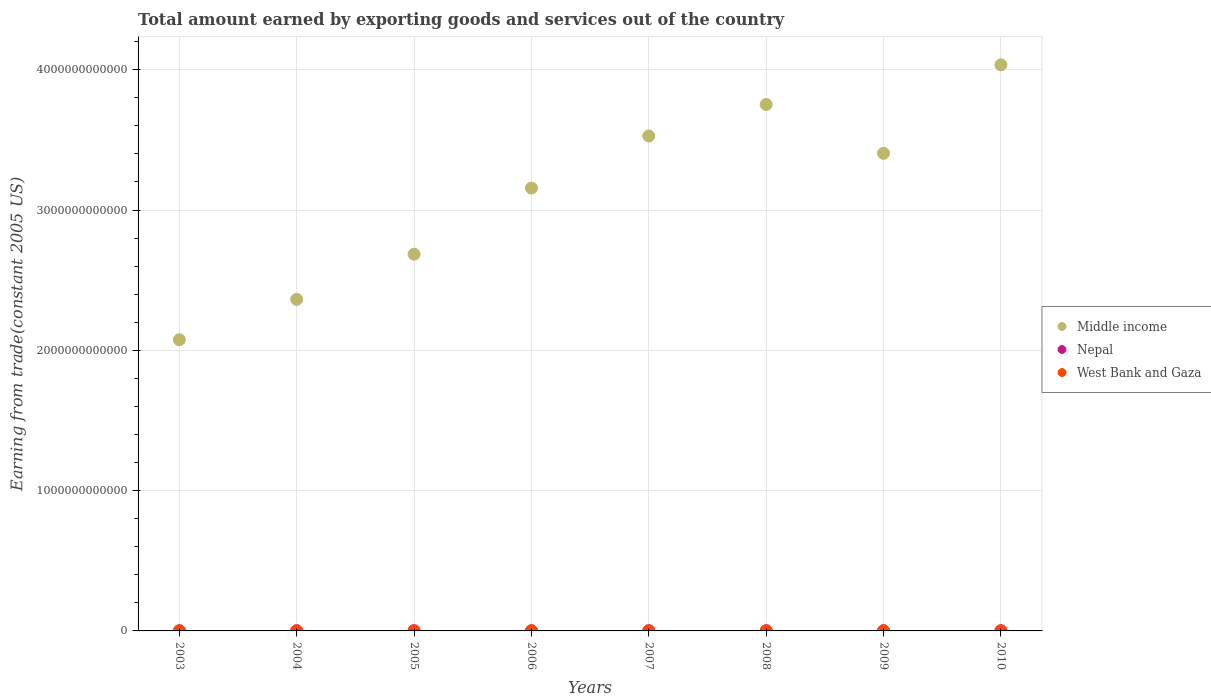What is the total amount earned by exporting goods and services in West Bank and Gaza in 2008?
Ensure brevity in your answer.  7.71e+08. Across all years, what is the maximum total amount earned by exporting goods and services in Middle income?
Offer a terse response. 4.03e+12. Across all years, what is the minimum total amount earned by exporting goods and services in West Bank and Gaza?
Your response must be concise. 5.62e+08. In which year was the total amount earned by exporting goods and services in Nepal maximum?
Provide a short and direct response. 2004. In which year was the total amount earned by exporting goods and services in West Bank and Gaza minimum?
Offer a terse response. 2003. What is the total total amount earned by exporting goods and services in Nepal in the graph?
Your answer should be very brief. 9.29e+09. What is the difference between the total amount earned by exporting goods and services in Nepal in 2007 and that in 2009?
Your answer should be compact. -5.36e+07. What is the difference between the total amount earned by exporting goods and services in Middle income in 2005 and the total amount earned by exporting goods and services in West Bank and Gaza in 2010?
Provide a succinct answer. 2.68e+12. What is the average total amount earned by exporting goods and services in Nepal per year?
Your answer should be compact. 1.16e+09. In the year 2009, what is the difference between the total amount earned by exporting goods and services in Middle income and total amount earned by exporting goods and services in Nepal?
Your answer should be very brief. 3.40e+12. In how many years, is the total amount earned by exporting goods and services in West Bank and Gaza greater than 2200000000000 US$?
Your answer should be very brief. 0. What is the ratio of the total amount earned by exporting goods and services in Middle income in 2005 to that in 2010?
Your answer should be very brief. 0.67. Is the difference between the total amount earned by exporting goods and services in Middle income in 2006 and 2009 greater than the difference between the total amount earned by exporting goods and services in Nepal in 2006 and 2009?
Ensure brevity in your answer.  No. What is the difference between the highest and the second highest total amount earned by exporting goods and services in Nepal?
Ensure brevity in your answer.  9.86e+06. What is the difference between the highest and the lowest total amount earned by exporting goods and services in West Bank and Gaza?
Offer a terse response. 3.54e+08. In how many years, is the total amount earned by exporting goods and services in Middle income greater than the average total amount earned by exporting goods and services in Middle income taken over all years?
Provide a succinct answer. 5. Is it the case that in every year, the sum of the total amount earned by exporting goods and services in Nepal and total amount earned by exporting goods and services in West Bank and Gaza  is greater than the total amount earned by exporting goods and services in Middle income?
Ensure brevity in your answer.  No. Does the total amount earned by exporting goods and services in West Bank and Gaza monotonically increase over the years?
Keep it short and to the point. No. Is the total amount earned by exporting goods and services in West Bank and Gaza strictly greater than the total amount earned by exporting goods and services in Middle income over the years?
Provide a succinct answer. No. Is the total amount earned by exporting goods and services in Nepal strictly less than the total amount earned by exporting goods and services in West Bank and Gaza over the years?
Your answer should be compact. No. How many dotlines are there?
Keep it short and to the point. 3. How many years are there in the graph?
Give a very brief answer. 8. What is the difference between two consecutive major ticks on the Y-axis?
Offer a terse response. 1.00e+12. Does the graph contain any zero values?
Offer a very short reply. No. How many legend labels are there?
Your answer should be compact. 3. How are the legend labels stacked?
Offer a very short reply. Vertical. What is the title of the graph?
Your answer should be compact. Total amount earned by exporting goods and services out of the country. What is the label or title of the Y-axis?
Your response must be concise. Earning from trade(constant 2005 US). What is the Earning from trade(constant 2005 US) in Middle income in 2003?
Offer a very short reply. 2.08e+12. What is the Earning from trade(constant 2005 US) of Nepal in 2003?
Keep it short and to the point. 1.09e+09. What is the Earning from trade(constant 2005 US) of West Bank and Gaza in 2003?
Ensure brevity in your answer.  5.62e+08. What is the Earning from trade(constant 2005 US) in Middle income in 2004?
Your answer should be compact. 2.36e+12. What is the Earning from trade(constant 2005 US) in Nepal in 2004?
Your response must be concise. 1.22e+09. What is the Earning from trade(constant 2005 US) of West Bank and Gaza in 2004?
Your answer should be compact. 6.12e+08. What is the Earning from trade(constant 2005 US) of Middle income in 2005?
Make the answer very short. 2.69e+12. What is the Earning from trade(constant 2005 US) of Nepal in 2005?
Give a very brief answer. 1.19e+09. What is the Earning from trade(constant 2005 US) in West Bank and Gaza in 2005?
Your response must be concise. 7.24e+08. What is the Earning from trade(constant 2005 US) of Middle income in 2006?
Make the answer very short. 3.16e+12. What is the Earning from trade(constant 2005 US) of Nepal in 2006?
Your answer should be very brief. 1.17e+09. What is the Earning from trade(constant 2005 US) of West Bank and Gaza in 2006?
Provide a succinct answer. 6.97e+08. What is the Earning from trade(constant 2005 US) in Middle income in 2007?
Offer a very short reply. 3.53e+12. What is the Earning from trade(constant 2005 US) in Nepal in 2007?
Make the answer very short. 1.16e+09. What is the Earning from trade(constant 2005 US) of West Bank and Gaza in 2007?
Your answer should be compact. 7.63e+08. What is the Earning from trade(constant 2005 US) of Middle income in 2008?
Your response must be concise. 3.75e+12. What is the Earning from trade(constant 2005 US) of Nepal in 2008?
Your answer should be very brief. 1.17e+09. What is the Earning from trade(constant 2005 US) in West Bank and Gaza in 2008?
Provide a succinct answer. 7.71e+08. What is the Earning from trade(constant 2005 US) of Middle income in 2009?
Offer a terse response. 3.40e+12. What is the Earning from trade(constant 2005 US) of Nepal in 2009?
Provide a succinct answer. 1.21e+09. What is the Earning from trade(constant 2005 US) of West Bank and Gaza in 2009?
Give a very brief answer. 9.15e+08. What is the Earning from trade(constant 2005 US) in Middle income in 2010?
Keep it short and to the point. 4.03e+12. What is the Earning from trade(constant 2005 US) in Nepal in 2010?
Keep it short and to the point. 1.09e+09. What is the Earning from trade(constant 2005 US) in West Bank and Gaza in 2010?
Give a very brief answer. 8.80e+08. Across all years, what is the maximum Earning from trade(constant 2005 US) in Middle income?
Give a very brief answer. 4.03e+12. Across all years, what is the maximum Earning from trade(constant 2005 US) of Nepal?
Offer a terse response. 1.22e+09. Across all years, what is the maximum Earning from trade(constant 2005 US) of West Bank and Gaza?
Your response must be concise. 9.15e+08. Across all years, what is the minimum Earning from trade(constant 2005 US) of Middle income?
Provide a short and direct response. 2.08e+12. Across all years, what is the minimum Earning from trade(constant 2005 US) in Nepal?
Ensure brevity in your answer.  1.09e+09. Across all years, what is the minimum Earning from trade(constant 2005 US) of West Bank and Gaza?
Offer a very short reply. 5.62e+08. What is the total Earning from trade(constant 2005 US) of Middle income in the graph?
Provide a short and direct response. 2.50e+13. What is the total Earning from trade(constant 2005 US) in Nepal in the graph?
Provide a succinct answer. 9.29e+09. What is the total Earning from trade(constant 2005 US) of West Bank and Gaza in the graph?
Ensure brevity in your answer.  5.92e+09. What is the difference between the Earning from trade(constant 2005 US) of Middle income in 2003 and that in 2004?
Your response must be concise. -2.88e+11. What is the difference between the Earning from trade(constant 2005 US) of Nepal in 2003 and that in 2004?
Provide a succinct answer. -1.34e+08. What is the difference between the Earning from trade(constant 2005 US) in West Bank and Gaza in 2003 and that in 2004?
Your answer should be compact. -5.02e+07. What is the difference between the Earning from trade(constant 2005 US) in Middle income in 2003 and that in 2005?
Provide a short and direct response. -6.10e+11. What is the difference between the Earning from trade(constant 2005 US) in Nepal in 2003 and that in 2005?
Keep it short and to the point. -9.66e+07. What is the difference between the Earning from trade(constant 2005 US) of West Bank and Gaza in 2003 and that in 2005?
Offer a very short reply. -1.62e+08. What is the difference between the Earning from trade(constant 2005 US) in Middle income in 2003 and that in 2006?
Make the answer very short. -1.08e+12. What is the difference between the Earning from trade(constant 2005 US) of Nepal in 2003 and that in 2006?
Offer a very short reply. -8.13e+07. What is the difference between the Earning from trade(constant 2005 US) of West Bank and Gaza in 2003 and that in 2006?
Provide a succinct answer. -1.36e+08. What is the difference between the Earning from trade(constant 2005 US) in Middle income in 2003 and that in 2007?
Provide a succinct answer. -1.45e+12. What is the difference between the Earning from trade(constant 2005 US) in Nepal in 2003 and that in 2007?
Make the answer very short. -7.02e+07. What is the difference between the Earning from trade(constant 2005 US) in West Bank and Gaza in 2003 and that in 2007?
Provide a short and direct response. -2.02e+08. What is the difference between the Earning from trade(constant 2005 US) in Middle income in 2003 and that in 2008?
Provide a succinct answer. -1.68e+12. What is the difference between the Earning from trade(constant 2005 US) in Nepal in 2003 and that in 2008?
Provide a short and direct response. -7.86e+07. What is the difference between the Earning from trade(constant 2005 US) in West Bank and Gaza in 2003 and that in 2008?
Provide a succinct answer. -2.09e+08. What is the difference between the Earning from trade(constant 2005 US) in Middle income in 2003 and that in 2009?
Your response must be concise. -1.33e+12. What is the difference between the Earning from trade(constant 2005 US) of Nepal in 2003 and that in 2009?
Give a very brief answer. -1.24e+08. What is the difference between the Earning from trade(constant 2005 US) in West Bank and Gaza in 2003 and that in 2009?
Offer a terse response. -3.54e+08. What is the difference between the Earning from trade(constant 2005 US) of Middle income in 2003 and that in 2010?
Give a very brief answer. -1.96e+12. What is the difference between the Earning from trade(constant 2005 US) of Nepal in 2003 and that in 2010?
Keep it short and to the point. 2.77e+06. What is the difference between the Earning from trade(constant 2005 US) of West Bank and Gaza in 2003 and that in 2010?
Provide a short and direct response. -3.19e+08. What is the difference between the Earning from trade(constant 2005 US) in Middle income in 2004 and that in 2005?
Ensure brevity in your answer.  -3.22e+11. What is the difference between the Earning from trade(constant 2005 US) of Nepal in 2004 and that in 2005?
Offer a terse response. 3.71e+07. What is the difference between the Earning from trade(constant 2005 US) of West Bank and Gaza in 2004 and that in 2005?
Your answer should be very brief. -1.12e+08. What is the difference between the Earning from trade(constant 2005 US) in Middle income in 2004 and that in 2006?
Provide a short and direct response. -7.93e+11. What is the difference between the Earning from trade(constant 2005 US) in Nepal in 2004 and that in 2006?
Ensure brevity in your answer.  5.24e+07. What is the difference between the Earning from trade(constant 2005 US) of West Bank and Gaza in 2004 and that in 2006?
Give a very brief answer. -8.56e+07. What is the difference between the Earning from trade(constant 2005 US) of Middle income in 2004 and that in 2007?
Offer a terse response. -1.16e+12. What is the difference between the Earning from trade(constant 2005 US) in Nepal in 2004 and that in 2007?
Offer a very short reply. 6.35e+07. What is the difference between the Earning from trade(constant 2005 US) in West Bank and Gaza in 2004 and that in 2007?
Give a very brief answer. -1.51e+08. What is the difference between the Earning from trade(constant 2005 US) in Middle income in 2004 and that in 2008?
Give a very brief answer. -1.39e+12. What is the difference between the Earning from trade(constant 2005 US) in Nepal in 2004 and that in 2008?
Provide a succinct answer. 5.51e+07. What is the difference between the Earning from trade(constant 2005 US) in West Bank and Gaza in 2004 and that in 2008?
Ensure brevity in your answer.  -1.59e+08. What is the difference between the Earning from trade(constant 2005 US) of Middle income in 2004 and that in 2009?
Your answer should be very brief. -1.04e+12. What is the difference between the Earning from trade(constant 2005 US) of Nepal in 2004 and that in 2009?
Provide a short and direct response. 9.86e+06. What is the difference between the Earning from trade(constant 2005 US) in West Bank and Gaza in 2004 and that in 2009?
Your answer should be compact. -3.03e+08. What is the difference between the Earning from trade(constant 2005 US) of Middle income in 2004 and that in 2010?
Your answer should be compact. -1.67e+12. What is the difference between the Earning from trade(constant 2005 US) of Nepal in 2004 and that in 2010?
Offer a terse response. 1.36e+08. What is the difference between the Earning from trade(constant 2005 US) in West Bank and Gaza in 2004 and that in 2010?
Your answer should be very brief. -2.69e+08. What is the difference between the Earning from trade(constant 2005 US) of Middle income in 2005 and that in 2006?
Your response must be concise. -4.71e+11. What is the difference between the Earning from trade(constant 2005 US) of Nepal in 2005 and that in 2006?
Offer a very short reply. 1.53e+07. What is the difference between the Earning from trade(constant 2005 US) of West Bank and Gaza in 2005 and that in 2006?
Offer a very short reply. 2.63e+07. What is the difference between the Earning from trade(constant 2005 US) in Middle income in 2005 and that in 2007?
Your response must be concise. -8.43e+11. What is the difference between the Earning from trade(constant 2005 US) of Nepal in 2005 and that in 2007?
Keep it short and to the point. 2.64e+07. What is the difference between the Earning from trade(constant 2005 US) of West Bank and Gaza in 2005 and that in 2007?
Ensure brevity in your answer.  -3.95e+07. What is the difference between the Earning from trade(constant 2005 US) of Middle income in 2005 and that in 2008?
Keep it short and to the point. -1.07e+12. What is the difference between the Earning from trade(constant 2005 US) in Nepal in 2005 and that in 2008?
Provide a short and direct response. 1.80e+07. What is the difference between the Earning from trade(constant 2005 US) of West Bank and Gaza in 2005 and that in 2008?
Keep it short and to the point. -4.70e+07. What is the difference between the Earning from trade(constant 2005 US) of Middle income in 2005 and that in 2009?
Provide a short and direct response. -7.19e+11. What is the difference between the Earning from trade(constant 2005 US) of Nepal in 2005 and that in 2009?
Provide a succinct answer. -2.72e+07. What is the difference between the Earning from trade(constant 2005 US) of West Bank and Gaza in 2005 and that in 2009?
Keep it short and to the point. -1.91e+08. What is the difference between the Earning from trade(constant 2005 US) of Middle income in 2005 and that in 2010?
Keep it short and to the point. -1.35e+12. What is the difference between the Earning from trade(constant 2005 US) in Nepal in 2005 and that in 2010?
Provide a short and direct response. 9.94e+07. What is the difference between the Earning from trade(constant 2005 US) in West Bank and Gaza in 2005 and that in 2010?
Provide a succinct answer. -1.57e+08. What is the difference between the Earning from trade(constant 2005 US) of Middle income in 2006 and that in 2007?
Offer a terse response. -3.71e+11. What is the difference between the Earning from trade(constant 2005 US) in Nepal in 2006 and that in 2007?
Make the answer very short. 1.11e+07. What is the difference between the Earning from trade(constant 2005 US) in West Bank and Gaza in 2006 and that in 2007?
Offer a very short reply. -6.57e+07. What is the difference between the Earning from trade(constant 2005 US) of Middle income in 2006 and that in 2008?
Give a very brief answer. -5.96e+11. What is the difference between the Earning from trade(constant 2005 US) of Nepal in 2006 and that in 2008?
Your response must be concise. 2.63e+06. What is the difference between the Earning from trade(constant 2005 US) of West Bank and Gaza in 2006 and that in 2008?
Give a very brief answer. -7.32e+07. What is the difference between the Earning from trade(constant 2005 US) of Middle income in 2006 and that in 2009?
Keep it short and to the point. -2.48e+11. What is the difference between the Earning from trade(constant 2005 US) in Nepal in 2006 and that in 2009?
Make the answer very short. -4.26e+07. What is the difference between the Earning from trade(constant 2005 US) in West Bank and Gaza in 2006 and that in 2009?
Give a very brief answer. -2.18e+08. What is the difference between the Earning from trade(constant 2005 US) of Middle income in 2006 and that in 2010?
Your response must be concise. -8.78e+11. What is the difference between the Earning from trade(constant 2005 US) of Nepal in 2006 and that in 2010?
Your response must be concise. 8.40e+07. What is the difference between the Earning from trade(constant 2005 US) of West Bank and Gaza in 2006 and that in 2010?
Offer a terse response. -1.83e+08. What is the difference between the Earning from trade(constant 2005 US) in Middle income in 2007 and that in 2008?
Keep it short and to the point. -2.24e+11. What is the difference between the Earning from trade(constant 2005 US) in Nepal in 2007 and that in 2008?
Offer a very short reply. -8.43e+06. What is the difference between the Earning from trade(constant 2005 US) in West Bank and Gaza in 2007 and that in 2008?
Keep it short and to the point. -7.48e+06. What is the difference between the Earning from trade(constant 2005 US) of Middle income in 2007 and that in 2009?
Ensure brevity in your answer.  1.23e+11. What is the difference between the Earning from trade(constant 2005 US) in Nepal in 2007 and that in 2009?
Your answer should be very brief. -5.36e+07. What is the difference between the Earning from trade(constant 2005 US) in West Bank and Gaza in 2007 and that in 2009?
Give a very brief answer. -1.52e+08. What is the difference between the Earning from trade(constant 2005 US) of Middle income in 2007 and that in 2010?
Your response must be concise. -5.07e+11. What is the difference between the Earning from trade(constant 2005 US) of Nepal in 2007 and that in 2010?
Your response must be concise. 7.30e+07. What is the difference between the Earning from trade(constant 2005 US) of West Bank and Gaza in 2007 and that in 2010?
Your response must be concise. -1.17e+08. What is the difference between the Earning from trade(constant 2005 US) of Middle income in 2008 and that in 2009?
Ensure brevity in your answer.  3.48e+11. What is the difference between the Earning from trade(constant 2005 US) in Nepal in 2008 and that in 2009?
Your response must be concise. -4.52e+07. What is the difference between the Earning from trade(constant 2005 US) of West Bank and Gaza in 2008 and that in 2009?
Keep it short and to the point. -1.45e+08. What is the difference between the Earning from trade(constant 2005 US) of Middle income in 2008 and that in 2010?
Offer a terse response. -2.83e+11. What is the difference between the Earning from trade(constant 2005 US) in Nepal in 2008 and that in 2010?
Provide a succinct answer. 8.14e+07. What is the difference between the Earning from trade(constant 2005 US) of West Bank and Gaza in 2008 and that in 2010?
Give a very brief answer. -1.10e+08. What is the difference between the Earning from trade(constant 2005 US) in Middle income in 2009 and that in 2010?
Your response must be concise. -6.30e+11. What is the difference between the Earning from trade(constant 2005 US) of Nepal in 2009 and that in 2010?
Keep it short and to the point. 1.27e+08. What is the difference between the Earning from trade(constant 2005 US) in West Bank and Gaza in 2009 and that in 2010?
Keep it short and to the point. 3.47e+07. What is the difference between the Earning from trade(constant 2005 US) of Middle income in 2003 and the Earning from trade(constant 2005 US) of Nepal in 2004?
Provide a short and direct response. 2.07e+12. What is the difference between the Earning from trade(constant 2005 US) in Middle income in 2003 and the Earning from trade(constant 2005 US) in West Bank and Gaza in 2004?
Give a very brief answer. 2.07e+12. What is the difference between the Earning from trade(constant 2005 US) in Nepal in 2003 and the Earning from trade(constant 2005 US) in West Bank and Gaza in 2004?
Your answer should be very brief. 4.77e+08. What is the difference between the Earning from trade(constant 2005 US) of Middle income in 2003 and the Earning from trade(constant 2005 US) of Nepal in 2005?
Provide a short and direct response. 2.07e+12. What is the difference between the Earning from trade(constant 2005 US) in Middle income in 2003 and the Earning from trade(constant 2005 US) in West Bank and Gaza in 2005?
Your answer should be compact. 2.07e+12. What is the difference between the Earning from trade(constant 2005 US) in Nepal in 2003 and the Earning from trade(constant 2005 US) in West Bank and Gaza in 2005?
Offer a terse response. 3.65e+08. What is the difference between the Earning from trade(constant 2005 US) of Middle income in 2003 and the Earning from trade(constant 2005 US) of Nepal in 2006?
Your answer should be compact. 2.07e+12. What is the difference between the Earning from trade(constant 2005 US) in Middle income in 2003 and the Earning from trade(constant 2005 US) in West Bank and Gaza in 2006?
Give a very brief answer. 2.07e+12. What is the difference between the Earning from trade(constant 2005 US) of Nepal in 2003 and the Earning from trade(constant 2005 US) of West Bank and Gaza in 2006?
Offer a very short reply. 3.92e+08. What is the difference between the Earning from trade(constant 2005 US) of Middle income in 2003 and the Earning from trade(constant 2005 US) of Nepal in 2007?
Offer a very short reply. 2.07e+12. What is the difference between the Earning from trade(constant 2005 US) in Middle income in 2003 and the Earning from trade(constant 2005 US) in West Bank and Gaza in 2007?
Provide a succinct answer. 2.07e+12. What is the difference between the Earning from trade(constant 2005 US) in Nepal in 2003 and the Earning from trade(constant 2005 US) in West Bank and Gaza in 2007?
Your response must be concise. 3.26e+08. What is the difference between the Earning from trade(constant 2005 US) of Middle income in 2003 and the Earning from trade(constant 2005 US) of Nepal in 2008?
Provide a succinct answer. 2.07e+12. What is the difference between the Earning from trade(constant 2005 US) of Middle income in 2003 and the Earning from trade(constant 2005 US) of West Bank and Gaza in 2008?
Your response must be concise. 2.07e+12. What is the difference between the Earning from trade(constant 2005 US) of Nepal in 2003 and the Earning from trade(constant 2005 US) of West Bank and Gaza in 2008?
Your answer should be compact. 3.18e+08. What is the difference between the Earning from trade(constant 2005 US) in Middle income in 2003 and the Earning from trade(constant 2005 US) in Nepal in 2009?
Provide a short and direct response. 2.07e+12. What is the difference between the Earning from trade(constant 2005 US) in Middle income in 2003 and the Earning from trade(constant 2005 US) in West Bank and Gaza in 2009?
Provide a succinct answer. 2.07e+12. What is the difference between the Earning from trade(constant 2005 US) in Nepal in 2003 and the Earning from trade(constant 2005 US) in West Bank and Gaza in 2009?
Your answer should be compact. 1.74e+08. What is the difference between the Earning from trade(constant 2005 US) in Middle income in 2003 and the Earning from trade(constant 2005 US) in Nepal in 2010?
Ensure brevity in your answer.  2.07e+12. What is the difference between the Earning from trade(constant 2005 US) in Middle income in 2003 and the Earning from trade(constant 2005 US) in West Bank and Gaza in 2010?
Provide a short and direct response. 2.07e+12. What is the difference between the Earning from trade(constant 2005 US) in Nepal in 2003 and the Earning from trade(constant 2005 US) in West Bank and Gaza in 2010?
Your answer should be very brief. 2.09e+08. What is the difference between the Earning from trade(constant 2005 US) of Middle income in 2004 and the Earning from trade(constant 2005 US) of Nepal in 2005?
Provide a succinct answer. 2.36e+12. What is the difference between the Earning from trade(constant 2005 US) in Middle income in 2004 and the Earning from trade(constant 2005 US) in West Bank and Gaza in 2005?
Offer a very short reply. 2.36e+12. What is the difference between the Earning from trade(constant 2005 US) of Nepal in 2004 and the Earning from trade(constant 2005 US) of West Bank and Gaza in 2005?
Make the answer very short. 4.99e+08. What is the difference between the Earning from trade(constant 2005 US) in Middle income in 2004 and the Earning from trade(constant 2005 US) in Nepal in 2006?
Your answer should be very brief. 2.36e+12. What is the difference between the Earning from trade(constant 2005 US) in Middle income in 2004 and the Earning from trade(constant 2005 US) in West Bank and Gaza in 2006?
Keep it short and to the point. 2.36e+12. What is the difference between the Earning from trade(constant 2005 US) in Nepal in 2004 and the Earning from trade(constant 2005 US) in West Bank and Gaza in 2006?
Offer a terse response. 5.25e+08. What is the difference between the Earning from trade(constant 2005 US) in Middle income in 2004 and the Earning from trade(constant 2005 US) in Nepal in 2007?
Offer a very short reply. 2.36e+12. What is the difference between the Earning from trade(constant 2005 US) of Middle income in 2004 and the Earning from trade(constant 2005 US) of West Bank and Gaza in 2007?
Keep it short and to the point. 2.36e+12. What is the difference between the Earning from trade(constant 2005 US) of Nepal in 2004 and the Earning from trade(constant 2005 US) of West Bank and Gaza in 2007?
Provide a succinct answer. 4.60e+08. What is the difference between the Earning from trade(constant 2005 US) of Middle income in 2004 and the Earning from trade(constant 2005 US) of Nepal in 2008?
Offer a very short reply. 2.36e+12. What is the difference between the Earning from trade(constant 2005 US) in Middle income in 2004 and the Earning from trade(constant 2005 US) in West Bank and Gaza in 2008?
Give a very brief answer. 2.36e+12. What is the difference between the Earning from trade(constant 2005 US) in Nepal in 2004 and the Earning from trade(constant 2005 US) in West Bank and Gaza in 2008?
Offer a very short reply. 4.52e+08. What is the difference between the Earning from trade(constant 2005 US) of Middle income in 2004 and the Earning from trade(constant 2005 US) of Nepal in 2009?
Offer a very short reply. 2.36e+12. What is the difference between the Earning from trade(constant 2005 US) in Middle income in 2004 and the Earning from trade(constant 2005 US) in West Bank and Gaza in 2009?
Ensure brevity in your answer.  2.36e+12. What is the difference between the Earning from trade(constant 2005 US) of Nepal in 2004 and the Earning from trade(constant 2005 US) of West Bank and Gaza in 2009?
Your answer should be compact. 3.08e+08. What is the difference between the Earning from trade(constant 2005 US) in Middle income in 2004 and the Earning from trade(constant 2005 US) in Nepal in 2010?
Offer a very short reply. 2.36e+12. What is the difference between the Earning from trade(constant 2005 US) in Middle income in 2004 and the Earning from trade(constant 2005 US) in West Bank and Gaza in 2010?
Make the answer very short. 2.36e+12. What is the difference between the Earning from trade(constant 2005 US) of Nepal in 2004 and the Earning from trade(constant 2005 US) of West Bank and Gaza in 2010?
Offer a terse response. 3.42e+08. What is the difference between the Earning from trade(constant 2005 US) of Middle income in 2005 and the Earning from trade(constant 2005 US) of Nepal in 2006?
Keep it short and to the point. 2.68e+12. What is the difference between the Earning from trade(constant 2005 US) of Middle income in 2005 and the Earning from trade(constant 2005 US) of West Bank and Gaza in 2006?
Ensure brevity in your answer.  2.68e+12. What is the difference between the Earning from trade(constant 2005 US) in Nepal in 2005 and the Earning from trade(constant 2005 US) in West Bank and Gaza in 2006?
Provide a succinct answer. 4.88e+08. What is the difference between the Earning from trade(constant 2005 US) in Middle income in 2005 and the Earning from trade(constant 2005 US) in Nepal in 2007?
Provide a succinct answer. 2.68e+12. What is the difference between the Earning from trade(constant 2005 US) in Middle income in 2005 and the Earning from trade(constant 2005 US) in West Bank and Gaza in 2007?
Offer a terse response. 2.68e+12. What is the difference between the Earning from trade(constant 2005 US) of Nepal in 2005 and the Earning from trade(constant 2005 US) of West Bank and Gaza in 2007?
Provide a succinct answer. 4.23e+08. What is the difference between the Earning from trade(constant 2005 US) in Middle income in 2005 and the Earning from trade(constant 2005 US) in Nepal in 2008?
Ensure brevity in your answer.  2.68e+12. What is the difference between the Earning from trade(constant 2005 US) of Middle income in 2005 and the Earning from trade(constant 2005 US) of West Bank and Gaza in 2008?
Offer a terse response. 2.68e+12. What is the difference between the Earning from trade(constant 2005 US) of Nepal in 2005 and the Earning from trade(constant 2005 US) of West Bank and Gaza in 2008?
Ensure brevity in your answer.  4.15e+08. What is the difference between the Earning from trade(constant 2005 US) in Middle income in 2005 and the Earning from trade(constant 2005 US) in Nepal in 2009?
Your answer should be very brief. 2.68e+12. What is the difference between the Earning from trade(constant 2005 US) in Middle income in 2005 and the Earning from trade(constant 2005 US) in West Bank and Gaza in 2009?
Your answer should be very brief. 2.68e+12. What is the difference between the Earning from trade(constant 2005 US) of Nepal in 2005 and the Earning from trade(constant 2005 US) of West Bank and Gaza in 2009?
Offer a terse response. 2.71e+08. What is the difference between the Earning from trade(constant 2005 US) in Middle income in 2005 and the Earning from trade(constant 2005 US) in Nepal in 2010?
Ensure brevity in your answer.  2.68e+12. What is the difference between the Earning from trade(constant 2005 US) in Middle income in 2005 and the Earning from trade(constant 2005 US) in West Bank and Gaza in 2010?
Keep it short and to the point. 2.68e+12. What is the difference between the Earning from trade(constant 2005 US) of Nepal in 2005 and the Earning from trade(constant 2005 US) of West Bank and Gaza in 2010?
Ensure brevity in your answer.  3.05e+08. What is the difference between the Earning from trade(constant 2005 US) in Middle income in 2006 and the Earning from trade(constant 2005 US) in Nepal in 2007?
Your answer should be very brief. 3.16e+12. What is the difference between the Earning from trade(constant 2005 US) in Middle income in 2006 and the Earning from trade(constant 2005 US) in West Bank and Gaza in 2007?
Ensure brevity in your answer.  3.16e+12. What is the difference between the Earning from trade(constant 2005 US) of Nepal in 2006 and the Earning from trade(constant 2005 US) of West Bank and Gaza in 2007?
Provide a succinct answer. 4.07e+08. What is the difference between the Earning from trade(constant 2005 US) of Middle income in 2006 and the Earning from trade(constant 2005 US) of Nepal in 2008?
Offer a terse response. 3.16e+12. What is the difference between the Earning from trade(constant 2005 US) of Middle income in 2006 and the Earning from trade(constant 2005 US) of West Bank and Gaza in 2008?
Your response must be concise. 3.16e+12. What is the difference between the Earning from trade(constant 2005 US) of Nepal in 2006 and the Earning from trade(constant 2005 US) of West Bank and Gaza in 2008?
Provide a short and direct response. 4.00e+08. What is the difference between the Earning from trade(constant 2005 US) of Middle income in 2006 and the Earning from trade(constant 2005 US) of Nepal in 2009?
Your answer should be very brief. 3.16e+12. What is the difference between the Earning from trade(constant 2005 US) in Middle income in 2006 and the Earning from trade(constant 2005 US) in West Bank and Gaza in 2009?
Make the answer very short. 3.16e+12. What is the difference between the Earning from trade(constant 2005 US) of Nepal in 2006 and the Earning from trade(constant 2005 US) of West Bank and Gaza in 2009?
Ensure brevity in your answer.  2.55e+08. What is the difference between the Earning from trade(constant 2005 US) in Middle income in 2006 and the Earning from trade(constant 2005 US) in Nepal in 2010?
Your answer should be very brief. 3.16e+12. What is the difference between the Earning from trade(constant 2005 US) of Middle income in 2006 and the Earning from trade(constant 2005 US) of West Bank and Gaza in 2010?
Give a very brief answer. 3.16e+12. What is the difference between the Earning from trade(constant 2005 US) of Nepal in 2006 and the Earning from trade(constant 2005 US) of West Bank and Gaza in 2010?
Provide a short and direct response. 2.90e+08. What is the difference between the Earning from trade(constant 2005 US) in Middle income in 2007 and the Earning from trade(constant 2005 US) in Nepal in 2008?
Ensure brevity in your answer.  3.53e+12. What is the difference between the Earning from trade(constant 2005 US) in Middle income in 2007 and the Earning from trade(constant 2005 US) in West Bank and Gaza in 2008?
Provide a short and direct response. 3.53e+12. What is the difference between the Earning from trade(constant 2005 US) of Nepal in 2007 and the Earning from trade(constant 2005 US) of West Bank and Gaza in 2008?
Give a very brief answer. 3.89e+08. What is the difference between the Earning from trade(constant 2005 US) of Middle income in 2007 and the Earning from trade(constant 2005 US) of Nepal in 2009?
Your answer should be very brief. 3.53e+12. What is the difference between the Earning from trade(constant 2005 US) of Middle income in 2007 and the Earning from trade(constant 2005 US) of West Bank and Gaza in 2009?
Keep it short and to the point. 3.53e+12. What is the difference between the Earning from trade(constant 2005 US) of Nepal in 2007 and the Earning from trade(constant 2005 US) of West Bank and Gaza in 2009?
Make the answer very short. 2.44e+08. What is the difference between the Earning from trade(constant 2005 US) in Middle income in 2007 and the Earning from trade(constant 2005 US) in Nepal in 2010?
Keep it short and to the point. 3.53e+12. What is the difference between the Earning from trade(constant 2005 US) of Middle income in 2007 and the Earning from trade(constant 2005 US) of West Bank and Gaza in 2010?
Give a very brief answer. 3.53e+12. What is the difference between the Earning from trade(constant 2005 US) in Nepal in 2007 and the Earning from trade(constant 2005 US) in West Bank and Gaza in 2010?
Your answer should be very brief. 2.79e+08. What is the difference between the Earning from trade(constant 2005 US) in Middle income in 2008 and the Earning from trade(constant 2005 US) in Nepal in 2009?
Provide a short and direct response. 3.75e+12. What is the difference between the Earning from trade(constant 2005 US) in Middle income in 2008 and the Earning from trade(constant 2005 US) in West Bank and Gaza in 2009?
Offer a terse response. 3.75e+12. What is the difference between the Earning from trade(constant 2005 US) of Nepal in 2008 and the Earning from trade(constant 2005 US) of West Bank and Gaza in 2009?
Offer a very short reply. 2.53e+08. What is the difference between the Earning from trade(constant 2005 US) in Middle income in 2008 and the Earning from trade(constant 2005 US) in Nepal in 2010?
Your answer should be compact. 3.75e+12. What is the difference between the Earning from trade(constant 2005 US) of Middle income in 2008 and the Earning from trade(constant 2005 US) of West Bank and Gaza in 2010?
Make the answer very short. 3.75e+12. What is the difference between the Earning from trade(constant 2005 US) in Nepal in 2008 and the Earning from trade(constant 2005 US) in West Bank and Gaza in 2010?
Provide a succinct answer. 2.87e+08. What is the difference between the Earning from trade(constant 2005 US) in Middle income in 2009 and the Earning from trade(constant 2005 US) in Nepal in 2010?
Your response must be concise. 3.40e+12. What is the difference between the Earning from trade(constant 2005 US) of Middle income in 2009 and the Earning from trade(constant 2005 US) of West Bank and Gaza in 2010?
Keep it short and to the point. 3.40e+12. What is the difference between the Earning from trade(constant 2005 US) of Nepal in 2009 and the Earning from trade(constant 2005 US) of West Bank and Gaza in 2010?
Offer a terse response. 3.33e+08. What is the average Earning from trade(constant 2005 US) of Middle income per year?
Offer a very short reply. 3.13e+12. What is the average Earning from trade(constant 2005 US) in Nepal per year?
Ensure brevity in your answer.  1.16e+09. What is the average Earning from trade(constant 2005 US) of West Bank and Gaza per year?
Your answer should be compact. 7.40e+08. In the year 2003, what is the difference between the Earning from trade(constant 2005 US) of Middle income and Earning from trade(constant 2005 US) of Nepal?
Keep it short and to the point. 2.07e+12. In the year 2003, what is the difference between the Earning from trade(constant 2005 US) in Middle income and Earning from trade(constant 2005 US) in West Bank and Gaza?
Make the answer very short. 2.07e+12. In the year 2003, what is the difference between the Earning from trade(constant 2005 US) of Nepal and Earning from trade(constant 2005 US) of West Bank and Gaza?
Offer a terse response. 5.28e+08. In the year 2004, what is the difference between the Earning from trade(constant 2005 US) in Middle income and Earning from trade(constant 2005 US) in Nepal?
Keep it short and to the point. 2.36e+12. In the year 2004, what is the difference between the Earning from trade(constant 2005 US) of Middle income and Earning from trade(constant 2005 US) of West Bank and Gaza?
Provide a short and direct response. 2.36e+12. In the year 2004, what is the difference between the Earning from trade(constant 2005 US) in Nepal and Earning from trade(constant 2005 US) in West Bank and Gaza?
Keep it short and to the point. 6.11e+08. In the year 2005, what is the difference between the Earning from trade(constant 2005 US) in Middle income and Earning from trade(constant 2005 US) in Nepal?
Your response must be concise. 2.68e+12. In the year 2005, what is the difference between the Earning from trade(constant 2005 US) in Middle income and Earning from trade(constant 2005 US) in West Bank and Gaza?
Provide a short and direct response. 2.68e+12. In the year 2005, what is the difference between the Earning from trade(constant 2005 US) of Nepal and Earning from trade(constant 2005 US) of West Bank and Gaza?
Offer a terse response. 4.62e+08. In the year 2006, what is the difference between the Earning from trade(constant 2005 US) of Middle income and Earning from trade(constant 2005 US) of Nepal?
Provide a short and direct response. 3.16e+12. In the year 2006, what is the difference between the Earning from trade(constant 2005 US) of Middle income and Earning from trade(constant 2005 US) of West Bank and Gaza?
Make the answer very short. 3.16e+12. In the year 2006, what is the difference between the Earning from trade(constant 2005 US) of Nepal and Earning from trade(constant 2005 US) of West Bank and Gaza?
Your answer should be compact. 4.73e+08. In the year 2007, what is the difference between the Earning from trade(constant 2005 US) of Middle income and Earning from trade(constant 2005 US) of Nepal?
Offer a very short reply. 3.53e+12. In the year 2007, what is the difference between the Earning from trade(constant 2005 US) in Middle income and Earning from trade(constant 2005 US) in West Bank and Gaza?
Your answer should be compact. 3.53e+12. In the year 2007, what is the difference between the Earning from trade(constant 2005 US) of Nepal and Earning from trade(constant 2005 US) of West Bank and Gaza?
Your answer should be very brief. 3.96e+08. In the year 2008, what is the difference between the Earning from trade(constant 2005 US) of Middle income and Earning from trade(constant 2005 US) of Nepal?
Your response must be concise. 3.75e+12. In the year 2008, what is the difference between the Earning from trade(constant 2005 US) in Middle income and Earning from trade(constant 2005 US) in West Bank and Gaza?
Make the answer very short. 3.75e+12. In the year 2008, what is the difference between the Earning from trade(constant 2005 US) of Nepal and Earning from trade(constant 2005 US) of West Bank and Gaza?
Keep it short and to the point. 3.97e+08. In the year 2009, what is the difference between the Earning from trade(constant 2005 US) in Middle income and Earning from trade(constant 2005 US) in Nepal?
Provide a succinct answer. 3.40e+12. In the year 2009, what is the difference between the Earning from trade(constant 2005 US) of Middle income and Earning from trade(constant 2005 US) of West Bank and Gaza?
Your answer should be very brief. 3.40e+12. In the year 2009, what is the difference between the Earning from trade(constant 2005 US) of Nepal and Earning from trade(constant 2005 US) of West Bank and Gaza?
Give a very brief answer. 2.98e+08. In the year 2010, what is the difference between the Earning from trade(constant 2005 US) in Middle income and Earning from trade(constant 2005 US) in Nepal?
Ensure brevity in your answer.  4.03e+12. In the year 2010, what is the difference between the Earning from trade(constant 2005 US) in Middle income and Earning from trade(constant 2005 US) in West Bank and Gaza?
Keep it short and to the point. 4.03e+12. In the year 2010, what is the difference between the Earning from trade(constant 2005 US) of Nepal and Earning from trade(constant 2005 US) of West Bank and Gaza?
Give a very brief answer. 2.06e+08. What is the ratio of the Earning from trade(constant 2005 US) in Middle income in 2003 to that in 2004?
Provide a short and direct response. 0.88. What is the ratio of the Earning from trade(constant 2005 US) in Nepal in 2003 to that in 2004?
Offer a terse response. 0.89. What is the ratio of the Earning from trade(constant 2005 US) of West Bank and Gaza in 2003 to that in 2004?
Your answer should be compact. 0.92. What is the ratio of the Earning from trade(constant 2005 US) of Middle income in 2003 to that in 2005?
Your response must be concise. 0.77. What is the ratio of the Earning from trade(constant 2005 US) of Nepal in 2003 to that in 2005?
Ensure brevity in your answer.  0.92. What is the ratio of the Earning from trade(constant 2005 US) in West Bank and Gaza in 2003 to that in 2005?
Give a very brief answer. 0.78. What is the ratio of the Earning from trade(constant 2005 US) in Middle income in 2003 to that in 2006?
Ensure brevity in your answer.  0.66. What is the ratio of the Earning from trade(constant 2005 US) in Nepal in 2003 to that in 2006?
Offer a very short reply. 0.93. What is the ratio of the Earning from trade(constant 2005 US) of West Bank and Gaza in 2003 to that in 2006?
Offer a very short reply. 0.81. What is the ratio of the Earning from trade(constant 2005 US) in Middle income in 2003 to that in 2007?
Your answer should be very brief. 0.59. What is the ratio of the Earning from trade(constant 2005 US) in Nepal in 2003 to that in 2007?
Your response must be concise. 0.94. What is the ratio of the Earning from trade(constant 2005 US) in West Bank and Gaza in 2003 to that in 2007?
Provide a succinct answer. 0.74. What is the ratio of the Earning from trade(constant 2005 US) of Middle income in 2003 to that in 2008?
Your answer should be very brief. 0.55. What is the ratio of the Earning from trade(constant 2005 US) of Nepal in 2003 to that in 2008?
Provide a short and direct response. 0.93. What is the ratio of the Earning from trade(constant 2005 US) in West Bank and Gaza in 2003 to that in 2008?
Your answer should be very brief. 0.73. What is the ratio of the Earning from trade(constant 2005 US) of Middle income in 2003 to that in 2009?
Offer a very short reply. 0.61. What is the ratio of the Earning from trade(constant 2005 US) of Nepal in 2003 to that in 2009?
Provide a short and direct response. 0.9. What is the ratio of the Earning from trade(constant 2005 US) in West Bank and Gaza in 2003 to that in 2009?
Provide a short and direct response. 0.61. What is the ratio of the Earning from trade(constant 2005 US) of Middle income in 2003 to that in 2010?
Provide a succinct answer. 0.51. What is the ratio of the Earning from trade(constant 2005 US) in West Bank and Gaza in 2003 to that in 2010?
Offer a terse response. 0.64. What is the ratio of the Earning from trade(constant 2005 US) in Middle income in 2004 to that in 2005?
Offer a very short reply. 0.88. What is the ratio of the Earning from trade(constant 2005 US) of Nepal in 2004 to that in 2005?
Your response must be concise. 1.03. What is the ratio of the Earning from trade(constant 2005 US) in West Bank and Gaza in 2004 to that in 2005?
Offer a terse response. 0.85. What is the ratio of the Earning from trade(constant 2005 US) of Middle income in 2004 to that in 2006?
Ensure brevity in your answer.  0.75. What is the ratio of the Earning from trade(constant 2005 US) in Nepal in 2004 to that in 2006?
Offer a terse response. 1.04. What is the ratio of the Earning from trade(constant 2005 US) in West Bank and Gaza in 2004 to that in 2006?
Keep it short and to the point. 0.88. What is the ratio of the Earning from trade(constant 2005 US) in Middle income in 2004 to that in 2007?
Provide a succinct answer. 0.67. What is the ratio of the Earning from trade(constant 2005 US) in Nepal in 2004 to that in 2007?
Offer a very short reply. 1.05. What is the ratio of the Earning from trade(constant 2005 US) of West Bank and Gaza in 2004 to that in 2007?
Ensure brevity in your answer.  0.8. What is the ratio of the Earning from trade(constant 2005 US) in Middle income in 2004 to that in 2008?
Ensure brevity in your answer.  0.63. What is the ratio of the Earning from trade(constant 2005 US) in Nepal in 2004 to that in 2008?
Keep it short and to the point. 1.05. What is the ratio of the Earning from trade(constant 2005 US) of West Bank and Gaza in 2004 to that in 2008?
Provide a short and direct response. 0.79. What is the ratio of the Earning from trade(constant 2005 US) in Middle income in 2004 to that in 2009?
Your response must be concise. 0.69. What is the ratio of the Earning from trade(constant 2005 US) in Nepal in 2004 to that in 2009?
Ensure brevity in your answer.  1.01. What is the ratio of the Earning from trade(constant 2005 US) of West Bank and Gaza in 2004 to that in 2009?
Offer a very short reply. 0.67. What is the ratio of the Earning from trade(constant 2005 US) of Middle income in 2004 to that in 2010?
Provide a succinct answer. 0.59. What is the ratio of the Earning from trade(constant 2005 US) in Nepal in 2004 to that in 2010?
Provide a short and direct response. 1.13. What is the ratio of the Earning from trade(constant 2005 US) of West Bank and Gaza in 2004 to that in 2010?
Provide a short and direct response. 0.69. What is the ratio of the Earning from trade(constant 2005 US) in Middle income in 2005 to that in 2006?
Ensure brevity in your answer.  0.85. What is the ratio of the Earning from trade(constant 2005 US) in Nepal in 2005 to that in 2006?
Ensure brevity in your answer.  1.01. What is the ratio of the Earning from trade(constant 2005 US) in West Bank and Gaza in 2005 to that in 2006?
Your answer should be very brief. 1.04. What is the ratio of the Earning from trade(constant 2005 US) in Middle income in 2005 to that in 2007?
Your answer should be compact. 0.76. What is the ratio of the Earning from trade(constant 2005 US) of Nepal in 2005 to that in 2007?
Your answer should be very brief. 1.02. What is the ratio of the Earning from trade(constant 2005 US) in West Bank and Gaza in 2005 to that in 2007?
Keep it short and to the point. 0.95. What is the ratio of the Earning from trade(constant 2005 US) of Middle income in 2005 to that in 2008?
Provide a succinct answer. 0.72. What is the ratio of the Earning from trade(constant 2005 US) in Nepal in 2005 to that in 2008?
Provide a succinct answer. 1.02. What is the ratio of the Earning from trade(constant 2005 US) of West Bank and Gaza in 2005 to that in 2008?
Provide a succinct answer. 0.94. What is the ratio of the Earning from trade(constant 2005 US) in Middle income in 2005 to that in 2009?
Your answer should be compact. 0.79. What is the ratio of the Earning from trade(constant 2005 US) in Nepal in 2005 to that in 2009?
Give a very brief answer. 0.98. What is the ratio of the Earning from trade(constant 2005 US) in West Bank and Gaza in 2005 to that in 2009?
Keep it short and to the point. 0.79. What is the ratio of the Earning from trade(constant 2005 US) of Middle income in 2005 to that in 2010?
Offer a very short reply. 0.67. What is the ratio of the Earning from trade(constant 2005 US) of Nepal in 2005 to that in 2010?
Your answer should be very brief. 1.09. What is the ratio of the Earning from trade(constant 2005 US) of West Bank and Gaza in 2005 to that in 2010?
Your answer should be compact. 0.82. What is the ratio of the Earning from trade(constant 2005 US) in Middle income in 2006 to that in 2007?
Make the answer very short. 0.89. What is the ratio of the Earning from trade(constant 2005 US) in Nepal in 2006 to that in 2007?
Offer a terse response. 1.01. What is the ratio of the Earning from trade(constant 2005 US) in West Bank and Gaza in 2006 to that in 2007?
Keep it short and to the point. 0.91. What is the ratio of the Earning from trade(constant 2005 US) in Middle income in 2006 to that in 2008?
Your response must be concise. 0.84. What is the ratio of the Earning from trade(constant 2005 US) in West Bank and Gaza in 2006 to that in 2008?
Provide a succinct answer. 0.91. What is the ratio of the Earning from trade(constant 2005 US) in Middle income in 2006 to that in 2009?
Provide a short and direct response. 0.93. What is the ratio of the Earning from trade(constant 2005 US) in Nepal in 2006 to that in 2009?
Your answer should be compact. 0.96. What is the ratio of the Earning from trade(constant 2005 US) in West Bank and Gaza in 2006 to that in 2009?
Make the answer very short. 0.76. What is the ratio of the Earning from trade(constant 2005 US) of Middle income in 2006 to that in 2010?
Your answer should be very brief. 0.78. What is the ratio of the Earning from trade(constant 2005 US) in Nepal in 2006 to that in 2010?
Provide a short and direct response. 1.08. What is the ratio of the Earning from trade(constant 2005 US) of West Bank and Gaza in 2006 to that in 2010?
Offer a terse response. 0.79. What is the ratio of the Earning from trade(constant 2005 US) in Middle income in 2007 to that in 2008?
Ensure brevity in your answer.  0.94. What is the ratio of the Earning from trade(constant 2005 US) of West Bank and Gaza in 2007 to that in 2008?
Ensure brevity in your answer.  0.99. What is the ratio of the Earning from trade(constant 2005 US) of Middle income in 2007 to that in 2009?
Your answer should be very brief. 1.04. What is the ratio of the Earning from trade(constant 2005 US) of Nepal in 2007 to that in 2009?
Provide a succinct answer. 0.96. What is the ratio of the Earning from trade(constant 2005 US) in West Bank and Gaza in 2007 to that in 2009?
Provide a succinct answer. 0.83. What is the ratio of the Earning from trade(constant 2005 US) in Middle income in 2007 to that in 2010?
Your answer should be very brief. 0.87. What is the ratio of the Earning from trade(constant 2005 US) of Nepal in 2007 to that in 2010?
Your response must be concise. 1.07. What is the ratio of the Earning from trade(constant 2005 US) in West Bank and Gaza in 2007 to that in 2010?
Keep it short and to the point. 0.87. What is the ratio of the Earning from trade(constant 2005 US) of Middle income in 2008 to that in 2009?
Give a very brief answer. 1.1. What is the ratio of the Earning from trade(constant 2005 US) in Nepal in 2008 to that in 2009?
Your response must be concise. 0.96. What is the ratio of the Earning from trade(constant 2005 US) of West Bank and Gaza in 2008 to that in 2009?
Offer a very short reply. 0.84. What is the ratio of the Earning from trade(constant 2005 US) of Nepal in 2008 to that in 2010?
Offer a terse response. 1.07. What is the ratio of the Earning from trade(constant 2005 US) of West Bank and Gaza in 2008 to that in 2010?
Give a very brief answer. 0.88. What is the ratio of the Earning from trade(constant 2005 US) in Middle income in 2009 to that in 2010?
Ensure brevity in your answer.  0.84. What is the ratio of the Earning from trade(constant 2005 US) in Nepal in 2009 to that in 2010?
Give a very brief answer. 1.12. What is the ratio of the Earning from trade(constant 2005 US) of West Bank and Gaza in 2009 to that in 2010?
Your answer should be very brief. 1.04. What is the difference between the highest and the second highest Earning from trade(constant 2005 US) of Middle income?
Keep it short and to the point. 2.83e+11. What is the difference between the highest and the second highest Earning from trade(constant 2005 US) of Nepal?
Ensure brevity in your answer.  9.86e+06. What is the difference between the highest and the second highest Earning from trade(constant 2005 US) in West Bank and Gaza?
Give a very brief answer. 3.47e+07. What is the difference between the highest and the lowest Earning from trade(constant 2005 US) of Middle income?
Your answer should be compact. 1.96e+12. What is the difference between the highest and the lowest Earning from trade(constant 2005 US) in Nepal?
Provide a short and direct response. 1.36e+08. What is the difference between the highest and the lowest Earning from trade(constant 2005 US) in West Bank and Gaza?
Ensure brevity in your answer.  3.54e+08. 